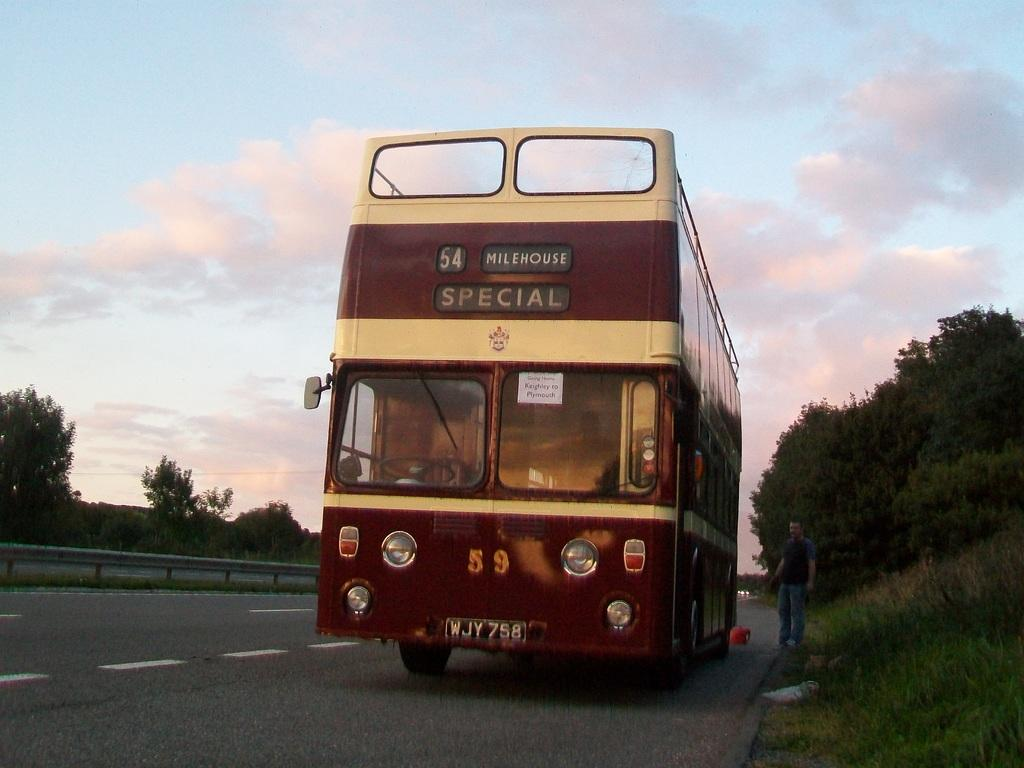What type of vehicle is on the road in the image? There is a bus on the road in the image. Can you describe the person near the bus? A person is standing beside the bus. What type of vegetation is visible in the image? There is grass visible in the image. What else can be seen in the image besides the bus and the person? There are trees in the image. What is visible in the background of the image? The sky is visible in the background of the image. Can you describe the sky in the image? Clouds are present in the sky. How much wealth does the sack of money on the bus represent in the image? There is no sack of money present in the image, so it is not possible to determine the amount of wealth it might represent. 